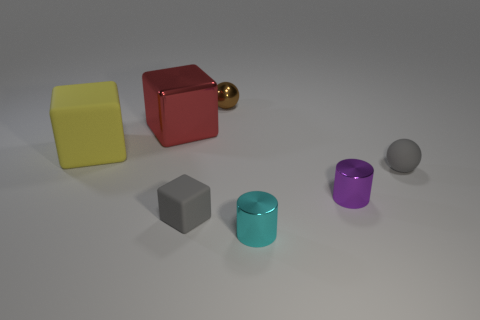Are there any red metallic spheres that have the same size as the brown shiny object?
Your response must be concise. No. Does the big matte object have the same shape as the small cyan object that is on the right side of the brown metallic thing?
Ensure brevity in your answer.  No. There is a matte thing that is right of the purple thing; does it have the same size as the sphere that is on the left side of the small rubber sphere?
Ensure brevity in your answer.  Yes. How many other things are there of the same shape as the brown object?
Provide a short and direct response. 1. What material is the cylinder behind the small shiny cylinder in front of the tiny purple metal thing made of?
Provide a short and direct response. Metal. What number of metal objects are either small red things or tiny cyan things?
Offer a terse response. 1. Are there any small rubber objects that are to the right of the shiny thing to the right of the cyan metallic cylinder?
Your response must be concise. Yes. How many things are either blocks in front of the yellow block or metallic things that are behind the big yellow block?
Your answer should be very brief. 3. Is there anything else of the same color as the big shiny object?
Offer a terse response. No. What color is the small sphere that is right of the cylinder that is behind the tiny thing to the left of the tiny metal sphere?
Your answer should be very brief. Gray. 